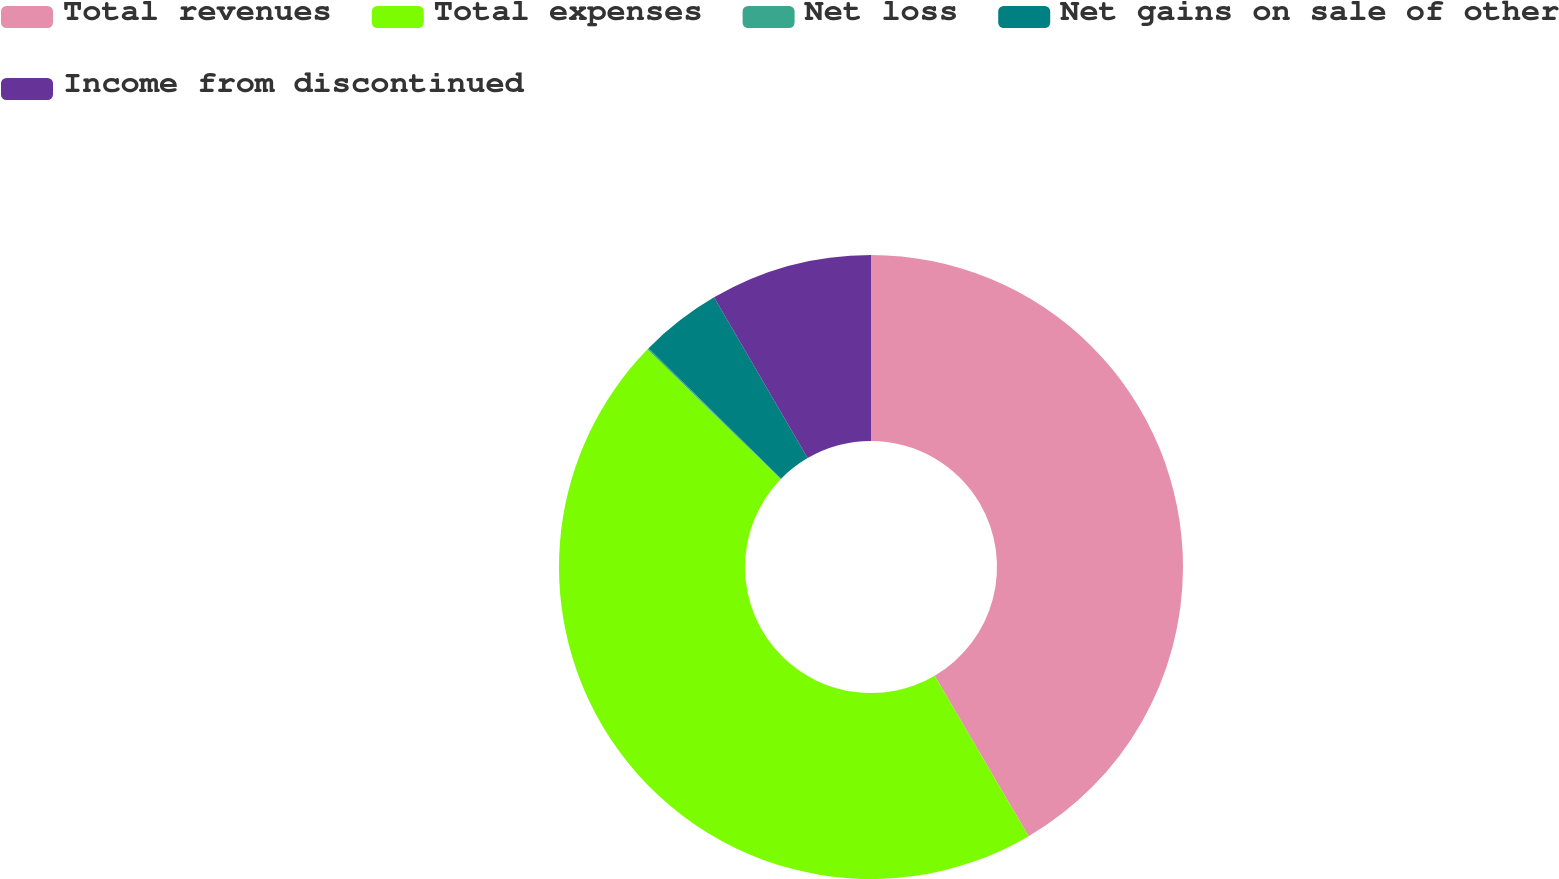Convert chart to OTSL. <chart><loc_0><loc_0><loc_500><loc_500><pie_chart><fcel>Total revenues<fcel>Total expenses<fcel>Net loss<fcel>Net gains on sale of other<fcel>Income from discontinued<nl><fcel>41.57%<fcel>45.72%<fcel>0.08%<fcel>4.24%<fcel>8.39%<nl></chart> 